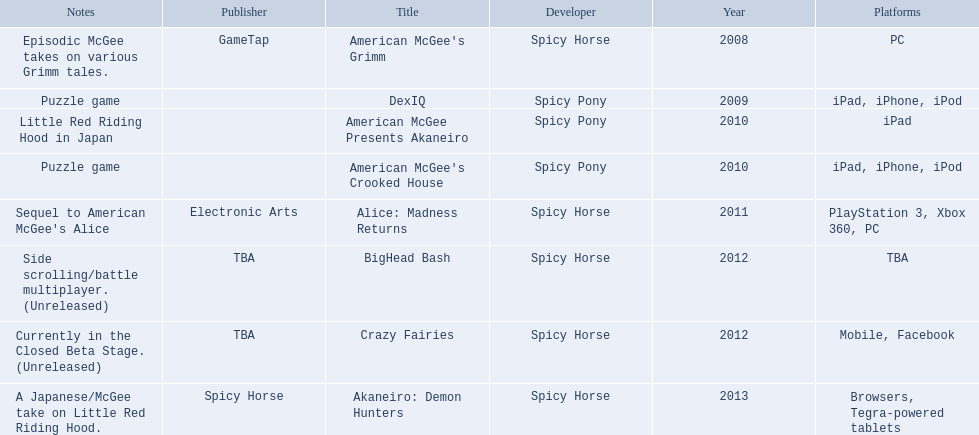What are all of the titles? American McGee's Grimm, DexIQ, American McGee Presents Akaneiro, American McGee's Crooked House, Alice: Madness Returns, BigHead Bash, Crazy Fairies, Akaneiro: Demon Hunters. Who published each title? GameTap, , , , Electronic Arts, TBA, TBA, Spicy Horse. Which game was published by electronics arts? Alice: Madness Returns. 